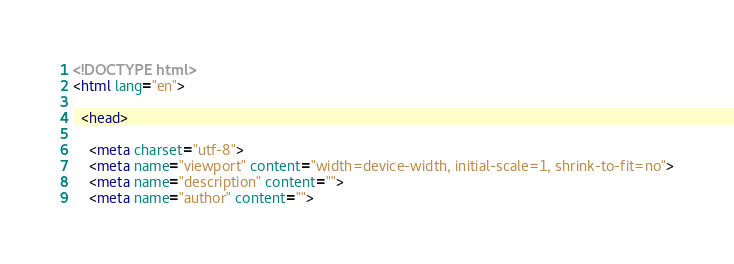<code> <loc_0><loc_0><loc_500><loc_500><_HTML_><!DOCTYPE html>
<html lang="en">

  <head>

    <meta charset="utf-8">
    <meta name="viewport" content="width=device-width, initial-scale=1, shrink-to-fit=no">
    <meta name="description" content="">
    <meta name="author" content="">
</code> 